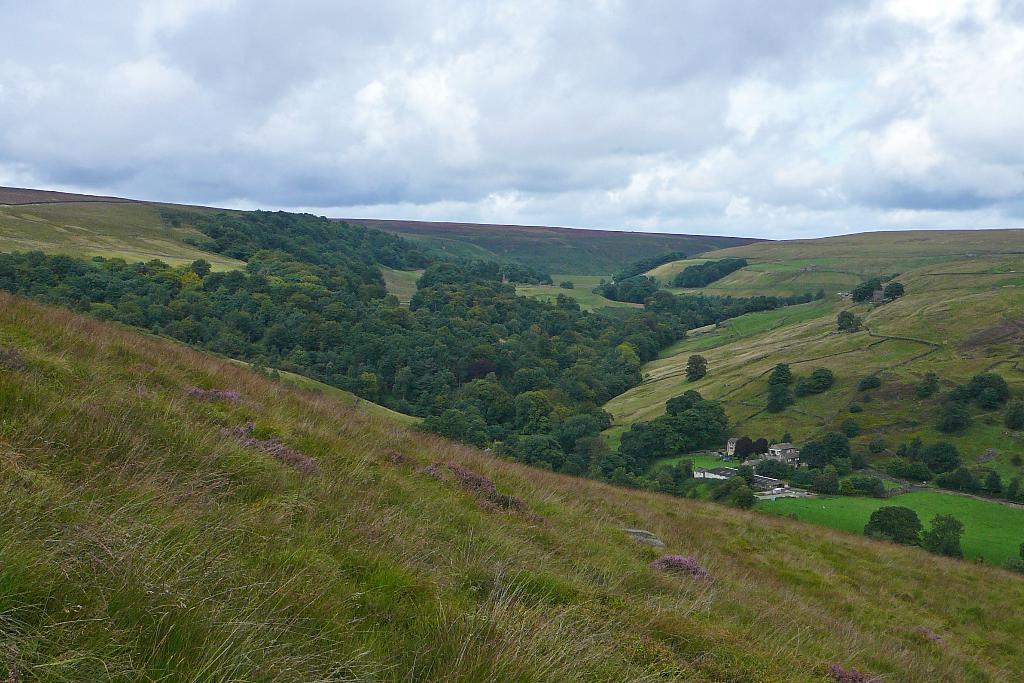In one or two sentences, can you explain what this image depicts? In this picture we can see some grass on the ground. There are trees, other objects and the cloudy sky. 